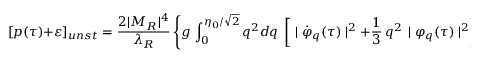<formula> <loc_0><loc_0><loc_500><loc_500>[ p ( \tau ) + \varepsilon ] _ { u n s t } = \frac { 2 | M _ { R } | ^ { 4 } } { \lambda _ { R } } \left \{ g \, \int _ { 0 } ^ { \eta _ { 0 } / \sqrt { 2 } } q ^ { 2 } d q \, \left [ \, | { \dot { \varphi } } _ { q } ( \tau ) | ^ { 2 } + \frac { 1 } { 3 } \, q ^ { 2 } \, | { \varphi } _ { q } ( \tau ) | ^ { 2 } \right ] \right \} \, .</formula> 